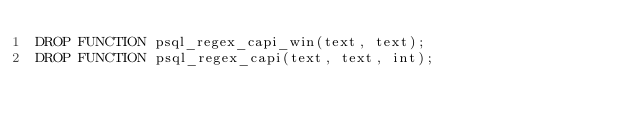Convert code to text. <code><loc_0><loc_0><loc_500><loc_500><_SQL_>DROP FUNCTION psql_regex_capi_win(text, text);
DROP FUNCTION psql_regex_capi(text, text, int);
</code> 